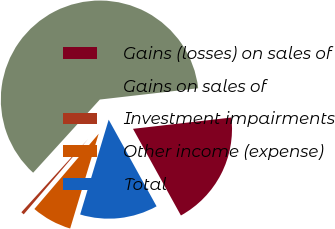Convert chart. <chart><loc_0><loc_0><loc_500><loc_500><pie_chart><fcel>Gains (losses) on sales of<fcel>Gains on sales of<fcel>Investment impairments<fcel>Other income (expense)<fcel>Total<nl><fcel>18.78%<fcel>61.42%<fcel>0.51%<fcel>6.6%<fcel>12.69%<nl></chart> 